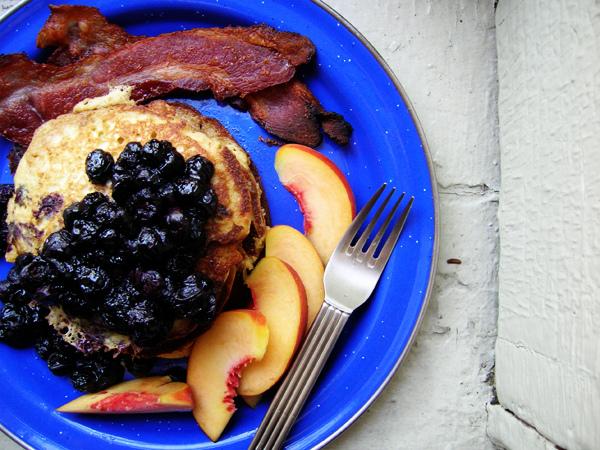What fruit is next to the fork?
Keep it brief. Peaches. Is this a spoon or a fork?
Answer briefly. Fork. What animal did the meat on the plate come from?
Be succinct. Pig. 